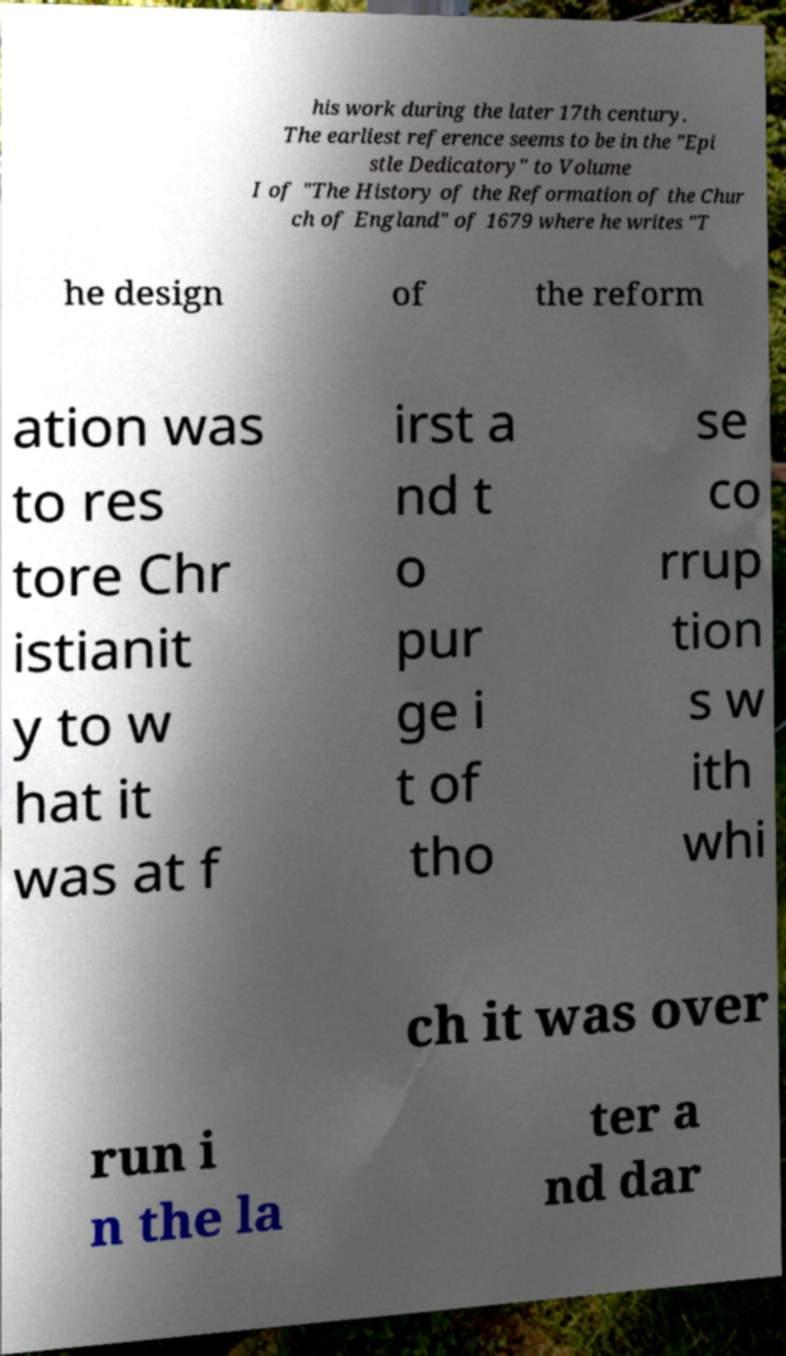What messages or text are displayed in this image? I need them in a readable, typed format. his work during the later 17th century. The earliest reference seems to be in the "Epi stle Dedicatory" to Volume I of "The History of the Reformation of the Chur ch of England" of 1679 where he writes "T he design of the reform ation was to res tore Chr istianit y to w hat it was at f irst a nd t o pur ge i t of tho se co rrup tion s w ith whi ch it was over run i n the la ter a nd dar 